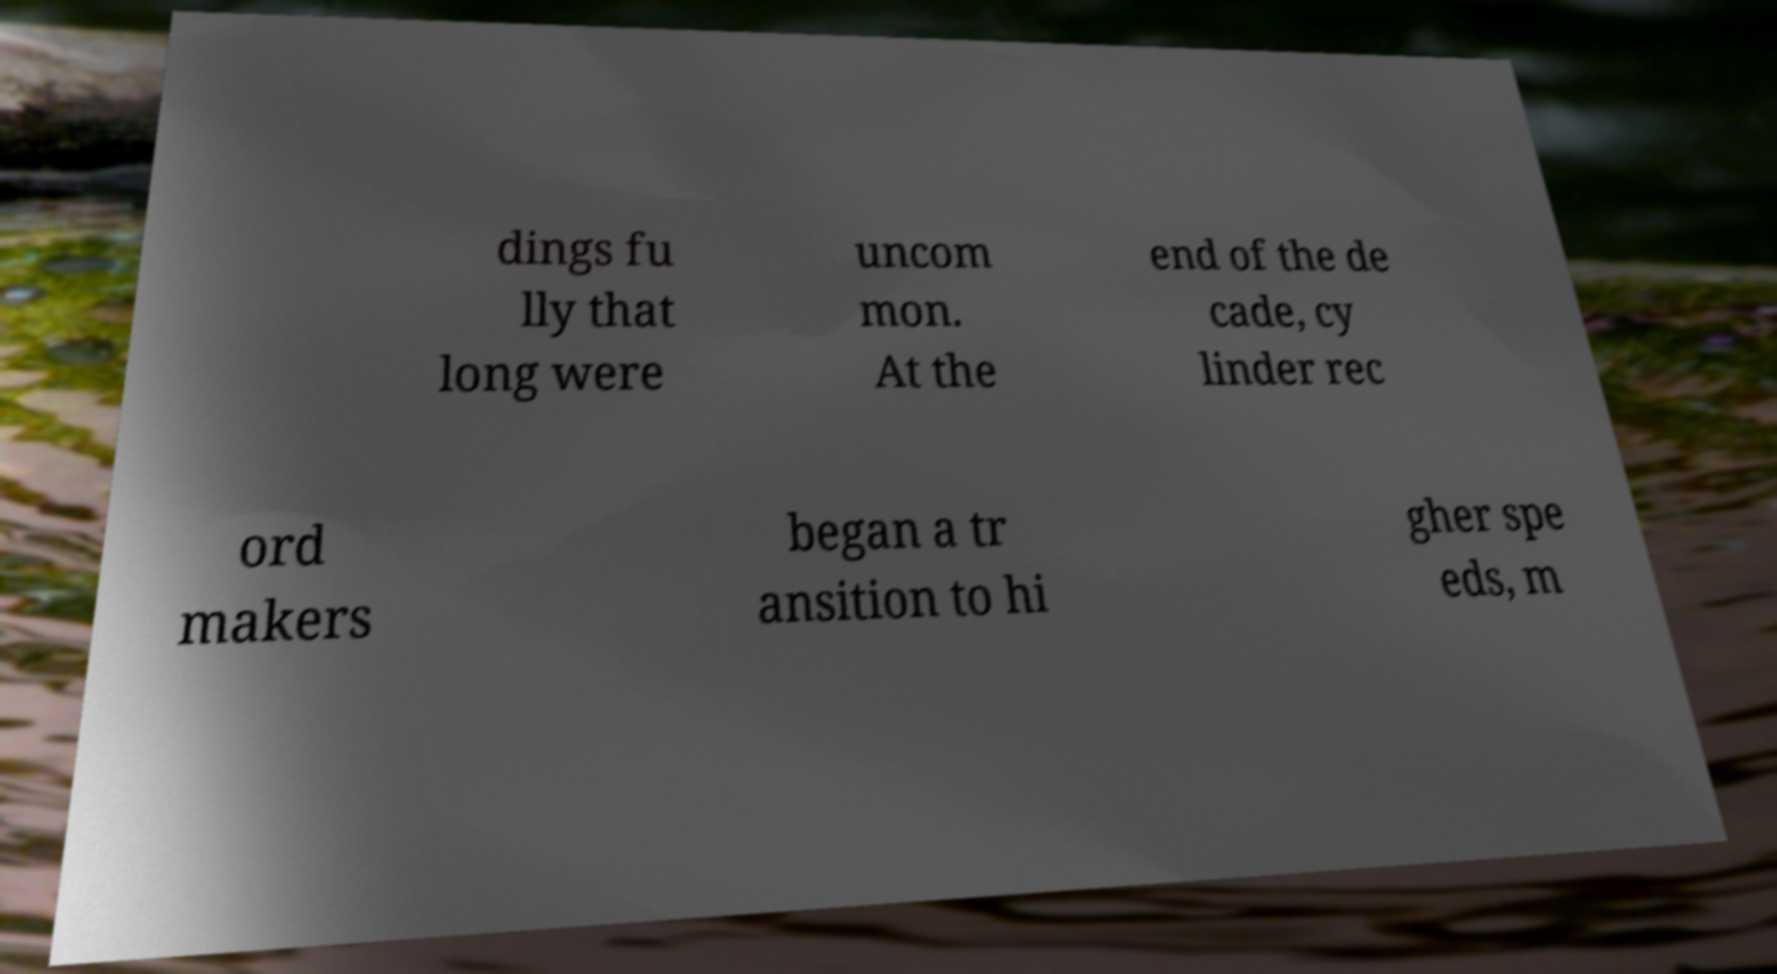Please read and relay the text visible in this image. What does it say? dings fu lly that long were uncom mon. At the end of the de cade, cy linder rec ord makers began a tr ansition to hi gher spe eds, m 